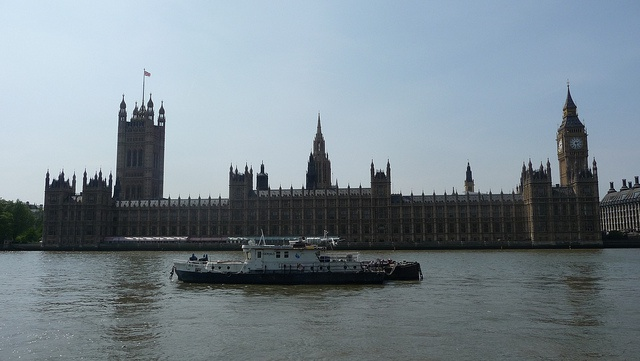Describe the objects in this image and their specific colors. I can see boat in lightblue, black, and purple tones, clock in lightblue, black, gray, and darkblue tones, and clock in lightblue, darkgray, gray, and black tones in this image. 